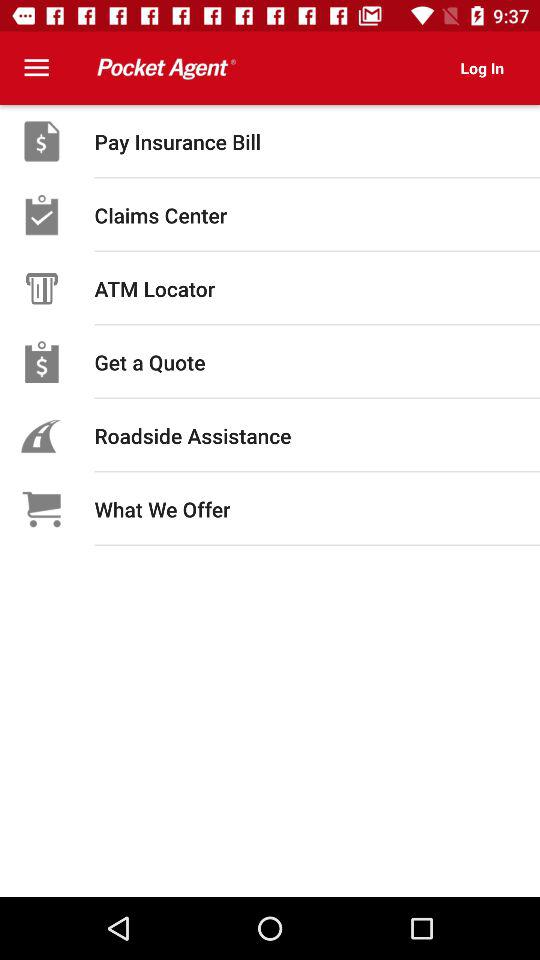What is the name of the application? The name of the application is "Pocket Agent". 